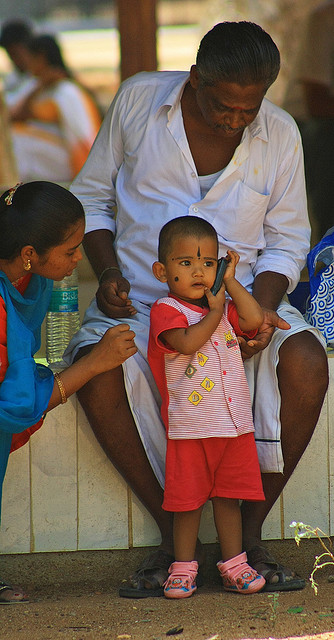Can you describe the interaction between the people in the image? Certainly! The image captures a tender moment between two individuals, likely family members. An older person, possibly a grandparent, is seated and appears to be gently holding the hand of a young child who stands beside them. This kind of interaction suggests a caring and protective relationship, where the elder is providing support or comfort to the child. 